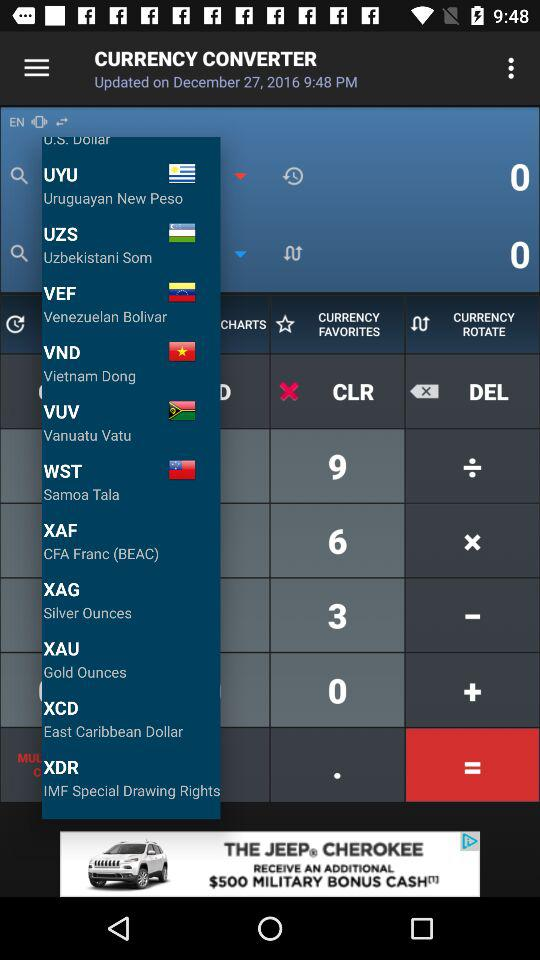What is the currency of Uzbekistan? The currency of Uzbekistan is the Uzbekistani Som. 